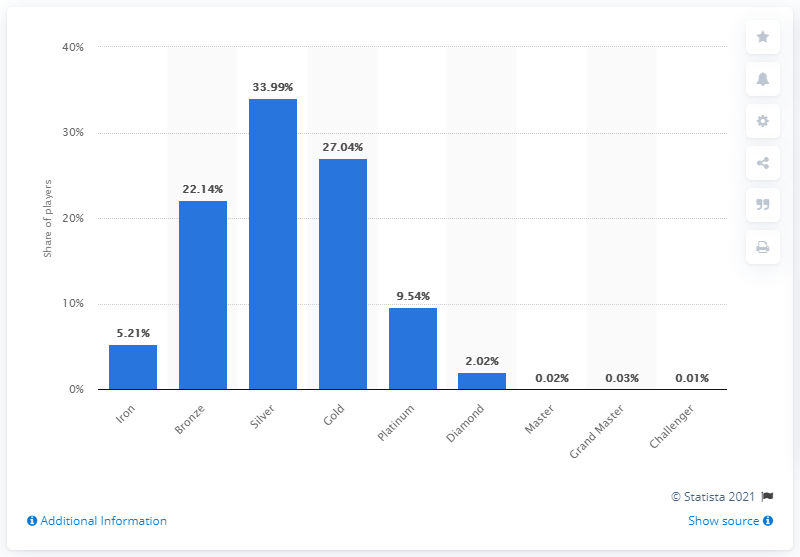List a handful of essential elements in this visual. According to the data, 33.99% of North American players have achieved the silver skill level. 